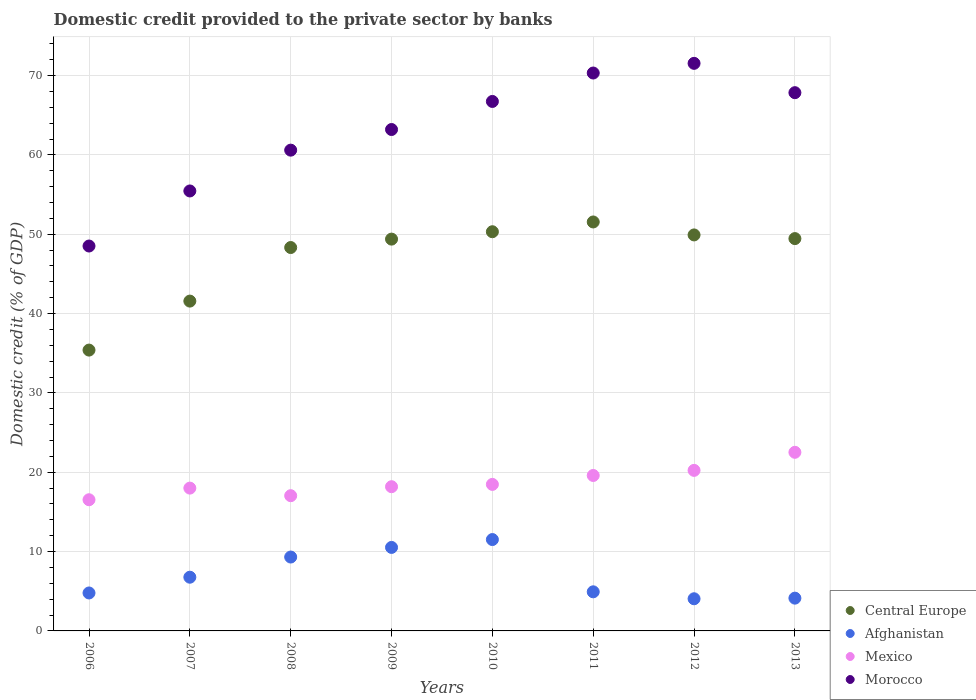How many different coloured dotlines are there?
Your response must be concise. 4. Is the number of dotlines equal to the number of legend labels?
Ensure brevity in your answer.  Yes. What is the domestic credit provided to the private sector by banks in Morocco in 2010?
Keep it short and to the point. 66.74. Across all years, what is the maximum domestic credit provided to the private sector by banks in Morocco?
Provide a succinct answer. 71.55. Across all years, what is the minimum domestic credit provided to the private sector by banks in Mexico?
Offer a terse response. 16.54. In which year was the domestic credit provided to the private sector by banks in Central Europe maximum?
Your answer should be very brief. 2011. What is the total domestic credit provided to the private sector by banks in Central Europe in the graph?
Your answer should be very brief. 375.93. What is the difference between the domestic credit provided to the private sector by banks in Afghanistan in 2007 and that in 2008?
Make the answer very short. -2.54. What is the difference between the domestic credit provided to the private sector by banks in Morocco in 2010 and the domestic credit provided to the private sector by banks in Central Europe in 2009?
Keep it short and to the point. 17.35. What is the average domestic credit provided to the private sector by banks in Mexico per year?
Make the answer very short. 18.82. In the year 2007, what is the difference between the domestic credit provided to the private sector by banks in Afghanistan and domestic credit provided to the private sector by banks in Morocco?
Your answer should be very brief. -48.69. What is the ratio of the domestic credit provided to the private sector by banks in Central Europe in 2007 to that in 2009?
Provide a short and direct response. 0.84. Is the difference between the domestic credit provided to the private sector by banks in Afghanistan in 2007 and 2010 greater than the difference between the domestic credit provided to the private sector by banks in Morocco in 2007 and 2010?
Offer a terse response. Yes. What is the difference between the highest and the second highest domestic credit provided to the private sector by banks in Morocco?
Ensure brevity in your answer.  1.22. What is the difference between the highest and the lowest domestic credit provided to the private sector by banks in Morocco?
Ensure brevity in your answer.  23.03. In how many years, is the domestic credit provided to the private sector by banks in Afghanistan greater than the average domestic credit provided to the private sector by banks in Afghanistan taken over all years?
Your answer should be very brief. 3. Is the sum of the domestic credit provided to the private sector by banks in Central Europe in 2008 and 2013 greater than the maximum domestic credit provided to the private sector by banks in Morocco across all years?
Your response must be concise. Yes. Is it the case that in every year, the sum of the domestic credit provided to the private sector by banks in Central Europe and domestic credit provided to the private sector by banks in Morocco  is greater than the sum of domestic credit provided to the private sector by banks in Afghanistan and domestic credit provided to the private sector by banks in Mexico?
Keep it short and to the point. No. Does the domestic credit provided to the private sector by banks in Morocco monotonically increase over the years?
Provide a succinct answer. No. How many dotlines are there?
Offer a terse response. 4. How many years are there in the graph?
Offer a terse response. 8. Are the values on the major ticks of Y-axis written in scientific E-notation?
Provide a succinct answer. No. Where does the legend appear in the graph?
Provide a short and direct response. Bottom right. How many legend labels are there?
Your answer should be compact. 4. What is the title of the graph?
Provide a short and direct response. Domestic credit provided to the private sector by banks. What is the label or title of the Y-axis?
Your response must be concise. Domestic credit (% of GDP). What is the Domestic credit (% of GDP) of Central Europe in 2006?
Give a very brief answer. 35.4. What is the Domestic credit (% of GDP) in Afghanistan in 2006?
Ensure brevity in your answer.  4.78. What is the Domestic credit (% of GDP) in Mexico in 2006?
Your answer should be compact. 16.54. What is the Domestic credit (% of GDP) of Morocco in 2006?
Ensure brevity in your answer.  48.52. What is the Domestic credit (% of GDP) of Central Europe in 2007?
Offer a very short reply. 41.58. What is the Domestic credit (% of GDP) of Afghanistan in 2007?
Keep it short and to the point. 6.77. What is the Domestic credit (% of GDP) of Mexico in 2007?
Offer a terse response. 18. What is the Domestic credit (% of GDP) of Morocco in 2007?
Offer a terse response. 55.46. What is the Domestic credit (% of GDP) of Central Europe in 2008?
Provide a succinct answer. 48.33. What is the Domestic credit (% of GDP) of Afghanistan in 2008?
Make the answer very short. 9.31. What is the Domestic credit (% of GDP) in Mexico in 2008?
Your answer should be compact. 17.05. What is the Domestic credit (% of GDP) in Morocco in 2008?
Your answer should be very brief. 60.6. What is the Domestic credit (% of GDP) in Central Europe in 2009?
Give a very brief answer. 49.39. What is the Domestic credit (% of GDP) in Afghanistan in 2009?
Offer a very short reply. 10.53. What is the Domestic credit (% of GDP) of Mexico in 2009?
Make the answer very short. 18.18. What is the Domestic credit (% of GDP) in Morocco in 2009?
Offer a terse response. 63.2. What is the Domestic credit (% of GDP) in Central Europe in 2010?
Make the answer very short. 50.32. What is the Domestic credit (% of GDP) of Afghanistan in 2010?
Provide a succinct answer. 11.52. What is the Domestic credit (% of GDP) in Mexico in 2010?
Provide a succinct answer. 18.47. What is the Domestic credit (% of GDP) of Morocco in 2010?
Ensure brevity in your answer.  66.74. What is the Domestic credit (% of GDP) in Central Europe in 2011?
Provide a short and direct response. 51.55. What is the Domestic credit (% of GDP) in Afghanistan in 2011?
Keep it short and to the point. 4.93. What is the Domestic credit (% of GDP) in Mexico in 2011?
Offer a very short reply. 19.59. What is the Domestic credit (% of GDP) in Morocco in 2011?
Your answer should be very brief. 70.33. What is the Domestic credit (% of GDP) of Central Europe in 2012?
Provide a short and direct response. 49.92. What is the Domestic credit (% of GDP) of Afghanistan in 2012?
Your answer should be very brief. 4.05. What is the Domestic credit (% of GDP) in Mexico in 2012?
Your answer should be very brief. 20.24. What is the Domestic credit (% of GDP) of Morocco in 2012?
Keep it short and to the point. 71.55. What is the Domestic credit (% of GDP) in Central Europe in 2013?
Make the answer very short. 49.45. What is the Domestic credit (% of GDP) in Afghanistan in 2013?
Your response must be concise. 4.13. What is the Domestic credit (% of GDP) in Mexico in 2013?
Your answer should be very brief. 22.52. What is the Domestic credit (% of GDP) of Morocco in 2013?
Your answer should be compact. 67.85. Across all years, what is the maximum Domestic credit (% of GDP) in Central Europe?
Offer a very short reply. 51.55. Across all years, what is the maximum Domestic credit (% of GDP) of Afghanistan?
Keep it short and to the point. 11.52. Across all years, what is the maximum Domestic credit (% of GDP) of Mexico?
Make the answer very short. 22.52. Across all years, what is the maximum Domestic credit (% of GDP) of Morocco?
Give a very brief answer. 71.55. Across all years, what is the minimum Domestic credit (% of GDP) in Central Europe?
Offer a very short reply. 35.4. Across all years, what is the minimum Domestic credit (% of GDP) of Afghanistan?
Keep it short and to the point. 4.05. Across all years, what is the minimum Domestic credit (% of GDP) in Mexico?
Your answer should be compact. 16.54. Across all years, what is the minimum Domestic credit (% of GDP) in Morocco?
Offer a very short reply. 48.52. What is the total Domestic credit (% of GDP) in Central Europe in the graph?
Ensure brevity in your answer.  375.93. What is the total Domestic credit (% of GDP) of Afghanistan in the graph?
Your answer should be very brief. 56.02. What is the total Domestic credit (% of GDP) in Mexico in the graph?
Give a very brief answer. 150.58. What is the total Domestic credit (% of GDP) in Morocco in the graph?
Ensure brevity in your answer.  504.25. What is the difference between the Domestic credit (% of GDP) in Central Europe in 2006 and that in 2007?
Provide a short and direct response. -6.18. What is the difference between the Domestic credit (% of GDP) of Afghanistan in 2006 and that in 2007?
Give a very brief answer. -1.99. What is the difference between the Domestic credit (% of GDP) in Mexico in 2006 and that in 2007?
Your answer should be very brief. -1.47. What is the difference between the Domestic credit (% of GDP) of Morocco in 2006 and that in 2007?
Offer a very short reply. -6.94. What is the difference between the Domestic credit (% of GDP) of Central Europe in 2006 and that in 2008?
Provide a succinct answer. -12.93. What is the difference between the Domestic credit (% of GDP) of Afghanistan in 2006 and that in 2008?
Your answer should be compact. -4.53. What is the difference between the Domestic credit (% of GDP) of Mexico in 2006 and that in 2008?
Ensure brevity in your answer.  -0.51. What is the difference between the Domestic credit (% of GDP) of Morocco in 2006 and that in 2008?
Offer a terse response. -12.08. What is the difference between the Domestic credit (% of GDP) of Central Europe in 2006 and that in 2009?
Offer a very short reply. -13.99. What is the difference between the Domestic credit (% of GDP) in Afghanistan in 2006 and that in 2009?
Ensure brevity in your answer.  -5.74. What is the difference between the Domestic credit (% of GDP) in Mexico in 2006 and that in 2009?
Ensure brevity in your answer.  -1.64. What is the difference between the Domestic credit (% of GDP) in Morocco in 2006 and that in 2009?
Offer a very short reply. -14.69. What is the difference between the Domestic credit (% of GDP) in Central Europe in 2006 and that in 2010?
Give a very brief answer. -14.92. What is the difference between the Domestic credit (% of GDP) in Afghanistan in 2006 and that in 2010?
Your answer should be very brief. -6.73. What is the difference between the Domestic credit (% of GDP) of Mexico in 2006 and that in 2010?
Make the answer very short. -1.93. What is the difference between the Domestic credit (% of GDP) in Morocco in 2006 and that in 2010?
Make the answer very short. -18.22. What is the difference between the Domestic credit (% of GDP) of Central Europe in 2006 and that in 2011?
Your answer should be compact. -16.15. What is the difference between the Domestic credit (% of GDP) of Afghanistan in 2006 and that in 2011?
Give a very brief answer. -0.14. What is the difference between the Domestic credit (% of GDP) of Mexico in 2006 and that in 2011?
Offer a very short reply. -3.06. What is the difference between the Domestic credit (% of GDP) in Morocco in 2006 and that in 2011?
Offer a terse response. -21.81. What is the difference between the Domestic credit (% of GDP) of Central Europe in 2006 and that in 2012?
Your answer should be compact. -14.52. What is the difference between the Domestic credit (% of GDP) of Afghanistan in 2006 and that in 2012?
Your answer should be very brief. 0.73. What is the difference between the Domestic credit (% of GDP) of Mexico in 2006 and that in 2012?
Your answer should be very brief. -3.7. What is the difference between the Domestic credit (% of GDP) in Morocco in 2006 and that in 2012?
Ensure brevity in your answer.  -23.03. What is the difference between the Domestic credit (% of GDP) of Central Europe in 2006 and that in 2013?
Give a very brief answer. -14.05. What is the difference between the Domestic credit (% of GDP) of Afghanistan in 2006 and that in 2013?
Offer a terse response. 0.65. What is the difference between the Domestic credit (% of GDP) of Mexico in 2006 and that in 2013?
Offer a very short reply. -5.98. What is the difference between the Domestic credit (% of GDP) in Morocco in 2006 and that in 2013?
Keep it short and to the point. -19.33. What is the difference between the Domestic credit (% of GDP) of Central Europe in 2007 and that in 2008?
Give a very brief answer. -6.75. What is the difference between the Domestic credit (% of GDP) of Afghanistan in 2007 and that in 2008?
Offer a very short reply. -2.54. What is the difference between the Domestic credit (% of GDP) in Mexico in 2007 and that in 2008?
Give a very brief answer. 0.96. What is the difference between the Domestic credit (% of GDP) in Morocco in 2007 and that in 2008?
Provide a short and direct response. -5.14. What is the difference between the Domestic credit (% of GDP) in Central Europe in 2007 and that in 2009?
Offer a terse response. -7.81. What is the difference between the Domestic credit (% of GDP) of Afghanistan in 2007 and that in 2009?
Give a very brief answer. -3.76. What is the difference between the Domestic credit (% of GDP) in Mexico in 2007 and that in 2009?
Provide a short and direct response. -0.18. What is the difference between the Domestic credit (% of GDP) in Morocco in 2007 and that in 2009?
Offer a terse response. -7.75. What is the difference between the Domestic credit (% of GDP) of Central Europe in 2007 and that in 2010?
Provide a short and direct response. -8.74. What is the difference between the Domestic credit (% of GDP) in Afghanistan in 2007 and that in 2010?
Offer a very short reply. -4.75. What is the difference between the Domestic credit (% of GDP) in Mexico in 2007 and that in 2010?
Offer a very short reply. -0.47. What is the difference between the Domestic credit (% of GDP) of Morocco in 2007 and that in 2010?
Your answer should be very brief. -11.28. What is the difference between the Domestic credit (% of GDP) of Central Europe in 2007 and that in 2011?
Ensure brevity in your answer.  -9.98. What is the difference between the Domestic credit (% of GDP) of Afghanistan in 2007 and that in 2011?
Your answer should be very brief. 1.84. What is the difference between the Domestic credit (% of GDP) in Mexico in 2007 and that in 2011?
Provide a short and direct response. -1.59. What is the difference between the Domestic credit (% of GDP) in Morocco in 2007 and that in 2011?
Your answer should be compact. -14.87. What is the difference between the Domestic credit (% of GDP) in Central Europe in 2007 and that in 2012?
Your answer should be compact. -8.34. What is the difference between the Domestic credit (% of GDP) of Afghanistan in 2007 and that in 2012?
Offer a very short reply. 2.72. What is the difference between the Domestic credit (% of GDP) in Mexico in 2007 and that in 2012?
Your answer should be very brief. -2.24. What is the difference between the Domestic credit (% of GDP) of Morocco in 2007 and that in 2012?
Offer a very short reply. -16.09. What is the difference between the Domestic credit (% of GDP) in Central Europe in 2007 and that in 2013?
Provide a succinct answer. -7.88. What is the difference between the Domestic credit (% of GDP) in Afghanistan in 2007 and that in 2013?
Provide a short and direct response. 2.64. What is the difference between the Domestic credit (% of GDP) of Mexico in 2007 and that in 2013?
Make the answer very short. -4.51. What is the difference between the Domestic credit (% of GDP) in Morocco in 2007 and that in 2013?
Keep it short and to the point. -12.39. What is the difference between the Domestic credit (% of GDP) of Central Europe in 2008 and that in 2009?
Your answer should be compact. -1.06. What is the difference between the Domestic credit (% of GDP) of Afghanistan in 2008 and that in 2009?
Keep it short and to the point. -1.21. What is the difference between the Domestic credit (% of GDP) in Mexico in 2008 and that in 2009?
Offer a very short reply. -1.13. What is the difference between the Domestic credit (% of GDP) in Morocco in 2008 and that in 2009?
Provide a succinct answer. -2.6. What is the difference between the Domestic credit (% of GDP) of Central Europe in 2008 and that in 2010?
Your response must be concise. -1.99. What is the difference between the Domestic credit (% of GDP) of Afghanistan in 2008 and that in 2010?
Offer a very short reply. -2.2. What is the difference between the Domestic credit (% of GDP) in Mexico in 2008 and that in 2010?
Your answer should be compact. -1.42. What is the difference between the Domestic credit (% of GDP) in Morocco in 2008 and that in 2010?
Your answer should be very brief. -6.14. What is the difference between the Domestic credit (% of GDP) in Central Europe in 2008 and that in 2011?
Your answer should be very brief. -3.22. What is the difference between the Domestic credit (% of GDP) of Afghanistan in 2008 and that in 2011?
Make the answer very short. 4.38. What is the difference between the Domestic credit (% of GDP) in Mexico in 2008 and that in 2011?
Offer a very short reply. -2.55. What is the difference between the Domestic credit (% of GDP) of Morocco in 2008 and that in 2011?
Keep it short and to the point. -9.72. What is the difference between the Domestic credit (% of GDP) of Central Europe in 2008 and that in 2012?
Your answer should be compact. -1.59. What is the difference between the Domestic credit (% of GDP) in Afghanistan in 2008 and that in 2012?
Your answer should be compact. 5.26. What is the difference between the Domestic credit (% of GDP) in Mexico in 2008 and that in 2012?
Your answer should be compact. -3.19. What is the difference between the Domestic credit (% of GDP) in Morocco in 2008 and that in 2012?
Your answer should be very brief. -10.94. What is the difference between the Domestic credit (% of GDP) in Central Europe in 2008 and that in 2013?
Your answer should be compact. -1.13. What is the difference between the Domestic credit (% of GDP) of Afghanistan in 2008 and that in 2013?
Offer a very short reply. 5.18. What is the difference between the Domestic credit (% of GDP) in Mexico in 2008 and that in 2013?
Provide a succinct answer. -5.47. What is the difference between the Domestic credit (% of GDP) of Morocco in 2008 and that in 2013?
Offer a very short reply. -7.24. What is the difference between the Domestic credit (% of GDP) of Central Europe in 2009 and that in 2010?
Your response must be concise. -0.93. What is the difference between the Domestic credit (% of GDP) of Afghanistan in 2009 and that in 2010?
Offer a very short reply. -0.99. What is the difference between the Domestic credit (% of GDP) in Mexico in 2009 and that in 2010?
Give a very brief answer. -0.29. What is the difference between the Domestic credit (% of GDP) in Morocco in 2009 and that in 2010?
Provide a succinct answer. -3.54. What is the difference between the Domestic credit (% of GDP) in Central Europe in 2009 and that in 2011?
Give a very brief answer. -2.16. What is the difference between the Domestic credit (% of GDP) in Afghanistan in 2009 and that in 2011?
Ensure brevity in your answer.  5.6. What is the difference between the Domestic credit (% of GDP) of Mexico in 2009 and that in 2011?
Your answer should be compact. -1.42. What is the difference between the Domestic credit (% of GDP) in Morocco in 2009 and that in 2011?
Ensure brevity in your answer.  -7.12. What is the difference between the Domestic credit (% of GDP) in Central Europe in 2009 and that in 2012?
Your response must be concise. -0.53. What is the difference between the Domestic credit (% of GDP) in Afghanistan in 2009 and that in 2012?
Offer a terse response. 6.47. What is the difference between the Domestic credit (% of GDP) of Mexico in 2009 and that in 2012?
Offer a terse response. -2.06. What is the difference between the Domestic credit (% of GDP) of Morocco in 2009 and that in 2012?
Your response must be concise. -8.34. What is the difference between the Domestic credit (% of GDP) of Central Europe in 2009 and that in 2013?
Provide a short and direct response. -0.07. What is the difference between the Domestic credit (% of GDP) in Afghanistan in 2009 and that in 2013?
Offer a terse response. 6.39. What is the difference between the Domestic credit (% of GDP) of Mexico in 2009 and that in 2013?
Provide a succinct answer. -4.34. What is the difference between the Domestic credit (% of GDP) of Morocco in 2009 and that in 2013?
Offer a very short reply. -4.64. What is the difference between the Domestic credit (% of GDP) in Central Europe in 2010 and that in 2011?
Your answer should be compact. -1.23. What is the difference between the Domestic credit (% of GDP) in Afghanistan in 2010 and that in 2011?
Provide a short and direct response. 6.59. What is the difference between the Domestic credit (% of GDP) in Mexico in 2010 and that in 2011?
Offer a terse response. -1.12. What is the difference between the Domestic credit (% of GDP) of Morocco in 2010 and that in 2011?
Make the answer very short. -3.58. What is the difference between the Domestic credit (% of GDP) of Central Europe in 2010 and that in 2012?
Provide a short and direct response. 0.4. What is the difference between the Domestic credit (% of GDP) of Afghanistan in 2010 and that in 2012?
Your response must be concise. 7.46. What is the difference between the Domestic credit (% of GDP) of Mexico in 2010 and that in 2012?
Provide a succinct answer. -1.77. What is the difference between the Domestic credit (% of GDP) in Morocco in 2010 and that in 2012?
Your answer should be very brief. -4.8. What is the difference between the Domestic credit (% of GDP) of Central Europe in 2010 and that in 2013?
Make the answer very short. 0.87. What is the difference between the Domestic credit (% of GDP) of Afghanistan in 2010 and that in 2013?
Keep it short and to the point. 7.39. What is the difference between the Domestic credit (% of GDP) in Mexico in 2010 and that in 2013?
Your answer should be compact. -4.05. What is the difference between the Domestic credit (% of GDP) of Morocco in 2010 and that in 2013?
Your answer should be very brief. -1.11. What is the difference between the Domestic credit (% of GDP) in Central Europe in 2011 and that in 2012?
Your answer should be compact. 1.63. What is the difference between the Domestic credit (% of GDP) of Mexico in 2011 and that in 2012?
Your answer should be compact. -0.64. What is the difference between the Domestic credit (% of GDP) in Morocco in 2011 and that in 2012?
Keep it short and to the point. -1.22. What is the difference between the Domestic credit (% of GDP) in Central Europe in 2011 and that in 2013?
Your answer should be very brief. 2.1. What is the difference between the Domestic credit (% of GDP) of Afghanistan in 2011 and that in 2013?
Give a very brief answer. 0.8. What is the difference between the Domestic credit (% of GDP) of Mexico in 2011 and that in 2013?
Keep it short and to the point. -2.92. What is the difference between the Domestic credit (% of GDP) of Morocco in 2011 and that in 2013?
Provide a succinct answer. 2.48. What is the difference between the Domestic credit (% of GDP) in Central Europe in 2012 and that in 2013?
Provide a short and direct response. 0.46. What is the difference between the Domestic credit (% of GDP) of Afghanistan in 2012 and that in 2013?
Provide a succinct answer. -0.08. What is the difference between the Domestic credit (% of GDP) of Mexico in 2012 and that in 2013?
Give a very brief answer. -2.28. What is the difference between the Domestic credit (% of GDP) in Morocco in 2012 and that in 2013?
Keep it short and to the point. 3.7. What is the difference between the Domestic credit (% of GDP) of Central Europe in 2006 and the Domestic credit (% of GDP) of Afghanistan in 2007?
Offer a terse response. 28.63. What is the difference between the Domestic credit (% of GDP) of Central Europe in 2006 and the Domestic credit (% of GDP) of Mexico in 2007?
Your answer should be compact. 17.4. What is the difference between the Domestic credit (% of GDP) of Central Europe in 2006 and the Domestic credit (% of GDP) of Morocco in 2007?
Offer a very short reply. -20.06. What is the difference between the Domestic credit (% of GDP) of Afghanistan in 2006 and the Domestic credit (% of GDP) of Mexico in 2007?
Provide a succinct answer. -13.22. What is the difference between the Domestic credit (% of GDP) in Afghanistan in 2006 and the Domestic credit (% of GDP) in Morocco in 2007?
Keep it short and to the point. -50.67. What is the difference between the Domestic credit (% of GDP) in Mexico in 2006 and the Domestic credit (% of GDP) in Morocco in 2007?
Ensure brevity in your answer.  -38.92. What is the difference between the Domestic credit (% of GDP) in Central Europe in 2006 and the Domestic credit (% of GDP) in Afghanistan in 2008?
Keep it short and to the point. 26.09. What is the difference between the Domestic credit (% of GDP) of Central Europe in 2006 and the Domestic credit (% of GDP) of Mexico in 2008?
Keep it short and to the point. 18.35. What is the difference between the Domestic credit (% of GDP) in Central Europe in 2006 and the Domestic credit (% of GDP) in Morocco in 2008?
Your answer should be compact. -25.2. What is the difference between the Domestic credit (% of GDP) in Afghanistan in 2006 and the Domestic credit (% of GDP) in Mexico in 2008?
Ensure brevity in your answer.  -12.26. What is the difference between the Domestic credit (% of GDP) in Afghanistan in 2006 and the Domestic credit (% of GDP) in Morocco in 2008?
Give a very brief answer. -55.82. What is the difference between the Domestic credit (% of GDP) in Mexico in 2006 and the Domestic credit (% of GDP) in Morocco in 2008?
Your answer should be very brief. -44.07. What is the difference between the Domestic credit (% of GDP) in Central Europe in 2006 and the Domestic credit (% of GDP) in Afghanistan in 2009?
Offer a terse response. 24.87. What is the difference between the Domestic credit (% of GDP) of Central Europe in 2006 and the Domestic credit (% of GDP) of Mexico in 2009?
Keep it short and to the point. 17.22. What is the difference between the Domestic credit (% of GDP) in Central Europe in 2006 and the Domestic credit (% of GDP) in Morocco in 2009?
Keep it short and to the point. -27.8. What is the difference between the Domestic credit (% of GDP) in Afghanistan in 2006 and the Domestic credit (% of GDP) in Mexico in 2009?
Give a very brief answer. -13.39. What is the difference between the Domestic credit (% of GDP) of Afghanistan in 2006 and the Domestic credit (% of GDP) of Morocco in 2009?
Give a very brief answer. -58.42. What is the difference between the Domestic credit (% of GDP) in Mexico in 2006 and the Domestic credit (% of GDP) in Morocco in 2009?
Your answer should be compact. -46.67. What is the difference between the Domestic credit (% of GDP) in Central Europe in 2006 and the Domestic credit (% of GDP) in Afghanistan in 2010?
Provide a succinct answer. 23.88. What is the difference between the Domestic credit (% of GDP) of Central Europe in 2006 and the Domestic credit (% of GDP) of Mexico in 2010?
Provide a short and direct response. 16.93. What is the difference between the Domestic credit (% of GDP) of Central Europe in 2006 and the Domestic credit (% of GDP) of Morocco in 2010?
Your response must be concise. -31.34. What is the difference between the Domestic credit (% of GDP) of Afghanistan in 2006 and the Domestic credit (% of GDP) of Mexico in 2010?
Your response must be concise. -13.69. What is the difference between the Domestic credit (% of GDP) of Afghanistan in 2006 and the Domestic credit (% of GDP) of Morocco in 2010?
Provide a short and direct response. -61.96. What is the difference between the Domestic credit (% of GDP) in Mexico in 2006 and the Domestic credit (% of GDP) in Morocco in 2010?
Provide a succinct answer. -50.21. What is the difference between the Domestic credit (% of GDP) in Central Europe in 2006 and the Domestic credit (% of GDP) in Afghanistan in 2011?
Provide a succinct answer. 30.47. What is the difference between the Domestic credit (% of GDP) of Central Europe in 2006 and the Domestic credit (% of GDP) of Mexico in 2011?
Offer a very short reply. 15.81. What is the difference between the Domestic credit (% of GDP) in Central Europe in 2006 and the Domestic credit (% of GDP) in Morocco in 2011?
Offer a terse response. -34.93. What is the difference between the Domestic credit (% of GDP) of Afghanistan in 2006 and the Domestic credit (% of GDP) of Mexico in 2011?
Your answer should be compact. -14.81. What is the difference between the Domestic credit (% of GDP) in Afghanistan in 2006 and the Domestic credit (% of GDP) in Morocco in 2011?
Offer a terse response. -65.54. What is the difference between the Domestic credit (% of GDP) of Mexico in 2006 and the Domestic credit (% of GDP) of Morocco in 2011?
Keep it short and to the point. -53.79. What is the difference between the Domestic credit (% of GDP) of Central Europe in 2006 and the Domestic credit (% of GDP) of Afghanistan in 2012?
Provide a short and direct response. 31.35. What is the difference between the Domestic credit (% of GDP) of Central Europe in 2006 and the Domestic credit (% of GDP) of Mexico in 2012?
Provide a short and direct response. 15.16. What is the difference between the Domestic credit (% of GDP) in Central Europe in 2006 and the Domestic credit (% of GDP) in Morocco in 2012?
Offer a terse response. -36.15. What is the difference between the Domestic credit (% of GDP) of Afghanistan in 2006 and the Domestic credit (% of GDP) of Mexico in 2012?
Provide a succinct answer. -15.45. What is the difference between the Domestic credit (% of GDP) in Afghanistan in 2006 and the Domestic credit (% of GDP) in Morocco in 2012?
Provide a succinct answer. -66.76. What is the difference between the Domestic credit (% of GDP) in Mexico in 2006 and the Domestic credit (% of GDP) in Morocco in 2012?
Your answer should be compact. -55.01. What is the difference between the Domestic credit (% of GDP) in Central Europe in 2006 and the Domestic credit (% of GDP) in Afghanistan in 2013?
Give a very brief answer. 31.27. What is the difference between the Domestic credit (% of GDP) of Central Europe in 2006 and the Domestic credit (% of GDP) of Mexico in 2013?
Give a very brief answer. 12.88. What is the difference between the Domestic credit (% of GDP) in Central Europe in 2006 and the Domestic credit (% of GDP) in Morocco in 2013?
Provide a short and direct response. -32.45. What is the difference between the Domestic credit (% of GDP) in Afghanistan in 2006 and the Domestic credit (% of GDP) in Mexico in 2013?
Give a very brief answer. -17.73. What is the difference between the Domestic credit (% of GDP) of Afghanistan in 2006 and the Domestic credit (% of GDP) of Morocco in 2013?
Provide a succinct answer. -63.06. What is the difference between the Domestic credit (% of GDP) in Mexico in 2006 and the Domestic credit (% of GDP) in Morocco in 2013?
Make the answer very short. -51.31. What is the difference between the Domestic credit (% of GDP) in Central Europe in 2007 and the Domestic credit (% of GDP) in Afghanistan in 2008?
Offer a very short reply. 32.26. What is the difference between the Domestic credit (% of GDP) of Central Europe in 2007 and the Domestic credit (% of GDP) of Mexico in 2008?
Your answer should be compact. 24.53. What is the difference between the Domestic credit (% of GDP) in Central Europe in 2007 and the Domestic credit (% of GDP) in Morocco in 2008?
Offer a terse response. -19.03. What is the difference between the Domestic credit (% of GDP) in Afghanistan in 2007 and the Domestic credit (% of GDP) in Mexico in 2008?
Ensure brevity in your answer.  -10.28. What is the difference between the Domestic credit (% of GDP) in Afghanistan in 2007 and the Domestic credit (% of GDP) in Morocco in 2008?
Provide a succinct answer. -53.83. What is the difference between the Domestic credit (% of GDP) of Mexico in 2007 and the Domestic credit (% of GDP) of Morocco in 2008?
Give a very brief answer. -42.6. What is the difference between the Domestic credit (% of GDP) of Central Europe in 2007 and the Domestic credit (% of GDP) of Afghanistan in 2009?
Your answer should be very brief. 31.05. What is the difference between the Domestic credit (% of GDP) of Central Europe in 2007 and the Domestic credit (% of GDP) of Mexico in 2009?
Provide a short and direct response. 23.4. What is the difference between the Domestic credit (% of GDP) of Central Europe in 2007 and the Domestic credit (% of GDP) of Morocco in 2009?
Make the answer very short. -21.63. What is the difference between the Domestic credit (% of GDP) in Afghanistan in 2007 and the Domestic credit (% of GDP) in Mexico in 2009?
Your answer should be compact. -11.41. What is the difference between the Domestic credit (% of GDP) in Afghanistan in 2007 and the Domestic credit (% of GDP) in Morocco in 2009?
Make the answer very short. -56.43. What is the difference between the Domestic credit (% of GDP) in Mexico in 2007 and the Domestic credit (% of GDP) in Morocco in 2009?
Your response must be concise. -45.2. What is the difference between the Domestic credit (% of GDP) of Central Europe in 2007 and the Domestic credit (% of GDP) of Afghanistan in 2010?
Provide a succinct answer. 30.06. What is the difference between the Domestic credit (% of GDP) in Central Europe in 2007 and the Domestic credit (% of GDP) in Mexico in 2010?
Offer a terse response. 23.11. What is the difference between the Domestic credit (% of GDP) in Central Europe in 2007 and the Domestic credit (% of GDP) in Morocco in 2010?
Give a very brief answer. -25.17. What is the difference between the Domestic credit (% of GDP) of Afghanistan in 2007 and the Domestic credit (% of GDP) of Mexico in 2010?
Give a very brief answer. -11.7. What is the difference between the Domestic credit (% of GDP) of Afghanistan in 2007 and the Domestic credit (% of GDP) of Morocco in 2010?
Offer a terse response. -59.97. What is the difference between the Domestic credit (% of GDP) of Mexico in 2007 and the Domestic credit (% of GDP) of Morocco in 2010?
Your answer should be very brief. -48.74. What is the difference between the Domestic credit (% of GDP) in Central Europe in 2007 and the Domestic credit (% of GDP) in Afghanistan in 2011?
Offer a very short reply. 36.65. What is the difference between the Domestic credit (% of GDP) of Central Europe in 2007 and the Domestic credit (% of GDP) of Mexico in 2011?
Your answer should be compact. 21.98. What is the difference between the Domestic credit (% of GDP) of Central Europe in 2007 and the Domestic credit (% of GDP) of Morocco in 2011?
Ensure brevity in your answer.  -28.75. What is the difference between the Domestic credit (% of GDP) of Afghanistan in 2007 and the Domestic credit (% of GDP) of Mexico in 2011?
Provide a short and direct response. -12.82. What is the difference between the Domestic credit (% of GDP) in Afghanistan in 2007 and the Domestic credit (% of GDP) in Morocco in 2011?
Offer a very short reply. -63.56. What is the difference between the Domestic credit (% of GDP) of Mexico in 2007 and the Domestic credit (% of GDP) of Morocco in 2011?
Your answer should be compact. -52.32. What is the difference between the Domestic credit (% of GDP) of Central Europe in 2007 and the Domestic credit (% of GDP) of Afghanistan in 2012?
Offer a very short reply. 37.52. What is the difference between the Domestic credit (% of GDP) in Central Europe in 2007 and the Domestic credit (% of GDP) in Mexico in 2012?
Your answer should be very brief. 21.34. What is the difference between the Domestic credit (% of GDP) of Central Europe in 2007 and the Domestic credit (% of GDP) of Morocco in 2012?
Provide a short and direct response. -29.97. What is the difference between the Domestic credit (% of GDP) of Afghanistan in 2007 and the Domestic credit (% of GDP) of Mexico in 2012?
Give a very brief answer. -13.47. What is the difference between the Domestic credit (% of GDP) of Afghanistan in 2007 and the Domestic credit (% of GDP) of Morocco in 2012?
Offer a terse response. -64.78. What is the difference between the Domestic credit (% of GDP) of Mexico in 2007 and the Domestic credit (% of GDP) of Morocco in 2012?
Ensure brevity in your answer.  -53.54. What is the difference between the Domestic credit (% of GDP) of Central Europe in 2007 and the Domestic credit (% of GDP) of Afghanistan in 2013?
Keep it short and to the point. 37.44. What is the difference between the Domestic credit (% of GDP) in Central Europe in 2007 and the Domestic credit (% of GDP) in Mexico in 2013?
Give a very brief answer. 19.06. What is the difference between the Domestic credit (% of GDP) of Central Europe in 2007 and the Domestic credit (% of GDP) of Morocco in 2013?
Your answer should be compact. -26.27. What is the difference between the Domestic credit (% of GDP) in Afghanistan in 2007 and the Domestic credit (% of GDP) in Mexico in 2013?
Provide a succinct answer. -15.75. What is the difference between the Domestic credit (% of GDP) in Afghanistan in 2007 and the Domestic credit (% of GDP) in Morocco in 2013?
Provide a succinct answer. -61.08. What is the difference between the Domestic credit (% of GDP) in Mexico in 2007 and the Domestic credit (% of GDP) in Morocco in 2013?
Your response must be concise. -49.85. What is the difference between the Domestic credit (% of GDP) of Central Europe in 2008 and the Domestic credit (% of GDP) of Afghanistan in 2009?
Offer a very short reply. 37.8. What is the difference between the Domestic credit (% of GDP) in Central Europe in 2008 and the Domestic credit (% of GDP) in Mexico in 2009?
Your answer should be very brief. 30.15. What is the difference between the Domestic credit (% of GDP) in Central Europe in 2008 and the Domestic credit (% of GDP) in Morocco in 2009?
Your answer should be very brief. -14.88. What is the difference between the Domestic credit (% of GDP) in Afghanistan in 2008 and the Domestic credit (% of GDP) in Mexico in 2009?
Provide a succinct answer. -8.87. What is the difference between the Domestic credit (% of GDP) of Afghanistan in 2008 and the Domestic credit (% of GDP) of Morocco in 2009?
Offer a very short reply. -53.89. What is the difference between the Domestic credit (% of GDP) in Mexico in 2008 and the Domestic credit (% of GDP) in Morocco in 2009?
Offer a very short reply. -46.16. What is the difference between the Domestic credit (% of GDP) of Central Europe in 2008 and the Domestic credit (% of GDP) of Afghanistan in 2010?
Your answer should be compact. 36.81. What is the difference between the Domestic credit (% of GDP) in Central Europe in 2008 and the Domestic credit (% of GDP) in Mexico in 2010?
Offer a very short reply. 29.86. What is the difference between the Domestic credit (% of GDP) of Central Europe in 2008 and the Domestic credit (% of GDP) of Morocco in 2010?
Offer a terse response. -18.41. What is the difference between the Domestic credit (% of GDP) in Afghanistan in 2008 and the Domestic credit (% of GDP) in Mexico in 2010?
Your answer should be very brief. -9.16. What is the difference between the Domestic credit (% of GDP) of Afghanistan in 2008 and the Domestic credit (% of GDP) of Morocco in 2010?
Your response must be concise. -57.43. What is the difference between the Domestic credit (% of GDP) in Mexico in 2008 and the Domestic credit (% of GDP) in Morocco in 2010?
Provide a short and direct response. -49.7. What is the difference between the Domestic credit (% of GDP) of Central Europe in 2008 and the Domestic credit (% of GDP) of Afghanistan in 2011?
Your answer should be very brief. 43.4. What is the difference between the Domestic credit (% of GDP) in Central Europe in 2008 and the Domestic credit (% of GDP) in Mexico in 2011?
Keep it short and to the point. 28.73. What is the difference between the Domestic credit (% of GDP) of Central Europe in 2008 and the Domestic credit (% of GDP) of Morocco in 2011?
Provide a short and direct response. -22. What is the difference between the Domestic credit (% of GDP) of Afghanistan in 2008 and the Domestic credit (% of GDP) of Mexico in 2011?
Provide a succinct answer. -10.28. What is the difference between the Domestic credit (% of GDP) in Afghanistan in 2008 and the Domestic credit (% of GDP) in Morocco in 2011?
Provide a succinct answer. -61.01. What is the difference between the Domestic credit (% of GDP) in Mexico in 2008 and the Domestic credit (% of GDP) in Morocco in 2011?
Keep it short and to the point. -53.28. What is the difference between the Domestic credit (% of GDP) in Central Europe in 2008 and the Domestic credit (% of GDP) in Afghanistan in 2012?
Give a very brief answer. 44.27. What is the difference between the Domestic credit (% of GDP) in Central Europe in 2008 and the Domestic credit (% of GDP) in Mexico in 2012?
Offer a very short reply. 28.09. What is the difference between the Domestic credit (% of GDP) in Central Europe in 2008 and the Domestic credit (% of GDP) in Morocco in 2012?
Give a very brief answer. -23.22. What is the difference between the Domestic credit (% of GDP) in Afghanistan in 2008 and the Domestic credit (% of GDP) in Mexico in 2012?
Ensure brevity in your answer.  -10.92. What is the difference between the Domestic credit (% of GDP) of Afghanistan in 2008 and the Domestic credit (% of GDP) of Morocco in 2012?
Give a very brief answer. -62.23. What is the difference between the Domestic credit (% of GDP) in Mexico in 2008 and the Domestic credit (% of GDP) in Morocco in 2012?
Offer a terse response. -54.5. What is the difference between the Domestic credit (% of GDP) in Central Europe in 2008 and the Domestic credit (% of GDP) in Afghanistan in 2013?
Offer a very short reply. 44.2. What is the difference between the Domestic credit (% of GDP) of Central Europe in 2008 and the Domestic credit (% of GDP) of Mexico in 2013?
Your answer should be very brief. 25.81. What is the difference between the Domestic credit (% of GDP) of Central Europe in 2008 and the Domestic credit (% of GDP) of Morocco in 2013?
Offer a terse response. -19.52. What is the difference between the Domestic credit (% of GDP) of Afghanistan in 2008 and the Domestic credit (% of GDP) of Mexico in 2013?
Your answer should be very brief. -13.2. What is the difference between the Domestic credit (% of GDP) of Afghanistan in 2008 and the Domestic credit (% of GDP) of Morocco in 2013?
Offer a terse response. -58.53. What is the difference between the Domestic credit (% of GDP) of Mexico in 2008 and the Domestic credit (% of GDP) of Morocco in 2013?
Offer a terse response. -50.8. What is the difference between the Domestic credit (% of GDP) of Central Europe in 2009 and the Domestic credit (% of GDP) of Afghanistan in 2010?
Your answer should be compact. 37.87. What is the difference between the Domestic credit (% of GDP) in Central Europe in 2009 and the Domestic credit (% of GDP) in Mexico in 2010?
Your response must be concise. 30.92. What is the difference between the Domestic credit (% of GDP) of Central Europe in 2009 and the Domestic credit (% of GDP) of Morocco in 2010?
Give a very brief answer. -17.35. What is the difference between the Domestic credit (% of GDP) of Afghanistan in 2009 and the Domestic credit (% of GDP) of Mexico in 2010?
Offer a terse response. -7.94. What is the difference between the Domestic credit (% of GDP) in Afghanistan in 2009 and the Domestic credit (% of GDP) in Morocco in 2010?
Offer a very short reply. -56.22. What is the difference between the Domestic credit (% of GDP) in Mexico in 2009 and the Domestic credit (% of GDP) in Morocco in 2010?
Offer a very short reply. -48.56. What is the difference between the Domestic credit (% of GDP) in Central Europe in 2009 and the Domestic credit (% of GDP) in Afghanistan in 2011?
Offer a terse response. 44.46. What is the difference between the Domestic credit (% of GDP) in Central Europe in 2009 and the Domestic credit (% of GDP) in Mexico in 2011?
Your answer should be very brief. 29.79. What is the difference between the Domestic credit (% of GDP) of Central Europe in 2009 and the Domestic credit (% of GDP) of Morocco in 2011?
Provide a short and direct response. -20.94. What is the difference between the Domestic credit (% of GDP) in Afghanistan in 2009 and the Domestic credit (% of GDP) in Mexico in 2011?
Ensure brevity in your answer.  -9.07. What is the difference between the Domestic credit (% of GDP) in Afghanistan in 2009 and the Domestic credit (% of GDP) in Morocco in 2011?
Offer a terse response. -59.8. What is the difference between the Domestic credit (% of GDP) in Mexico in 2009 and the Domestic credit (% of GDP) in Morocco in 2011?
Your response must be concise. -52.15. What is the difference between the Domestic credit (% of GDP) in Central Europe in 2009 and the Domestic credit (% of GDP) in Afghanistan in 2012?
Ensure brevity in your answer.  45.33. What is the difference between the Domestic credit (% of GDP) of Central Europe in 2009 and the Domestic credit (% of GDP) of Mexico in 2012?
Your answer should be very brief. 29.15. What is the difference between the Domestic credit (% of GDP) of Central Europe in 2009 and the Domestic credit (% of GDP) of Morocco in 2012?
Provide a succinct answer. -22.16. What is the difference between the Domestic credit (% of GDP) of Afghanistan in 2009 and the Domestic credit (% of GDP) of Mexico in 2012?
Your answer should be very brief. -9.71. What is the difference between the Domestic credit (% of GDP) in Afghanistan in 2009 and the Domestic credit (% of GDP) in Morocco in 2012?
Your answer should be very brief. -61.02. What is the difference between the Domestic credit (% of GDP) of Mexico in 2009 and the Domestic credit (% of GDP) of Morocco in 2012?
Offer a terse response. -53.37. What is the difference between the Domestic credit (% of GDP) in Central Europe in 2009 and the Domestic credit (% of GDP) in Afghanistan in 2013?
Make the answer very short. 45.26. What is the difference between the Domestic credit (% of GDP) of Central Europe in 2009 and the Domestic credit (% of GDP) of Mexico in 2013?
Your response must be concise. 26.87. What is the difference between the Domestic credit (% of GDP) in Central Europe in 2009 and the Domestic credit (% of GDP) in Morocco in 2013?
Provide a short and direct response. -18.46. What is the difference between the Domestic credit (% of GDP) of Afghanistan in 2009 and the Domestic credit (% of GDP) of Mexico in 2013?
Give a very brief answer. -11.99. What is the difference between the Domestic credit (% of GDP) in Afghanistan in 2009 and the Domestic credit (% of GDP) in Morocco in 2013?
Provide a short and direct response. -57.32. What is the difference between the Domestic credit (% of GDP) in Mexico in 2009 and the Domestic credit (% of GDP) in Morocco in 2013?
Ensure brevity in your answer.  -49.67. What is the difference between the Domestic credit (% of GDP) of Central Europe in 2010 and the Domestic credit (% of GDP) of Afghanistan in 2011?
Your response must be concise. 45.39. What is the difference between the Domestic credit (% of GDP) of Central Europe in 2010 and the Domestic credit (% of GDP) of Mexico in 2011?
Your response must be concise. 30.72. What is the difference between the Domestic credit (% of GDP) of Central Europe in 2010 and the Domestic credit (% of GDP) of Morocco in 2011?
Give a very brief answer. -20.01. What is the difference between the Domestic credit (% of GDP) of Afghanistan in 2010 and the Domestic credit (% of GDP) of Mexico in 2011?
Provide a succinct answer. -8.08. What is the difference between the Domestic credit (% of GDP) of Afghanistan in 2010 and the Domestic credit (% of GDP) of Morocco in 2011?
Your response must be concise. -58.81. What is the difference between the Domestic credit (% of GDP) in Mexico in 2010 and the Domestic credit (% of GDP) in Morocco in 2011?
Keep it short and to the point. -51.86. What is the difference between the Domestic credit (% of GDP) in Central Europe in 2010 and the Domestic credit (% of GDP) in Afghanistan in 2012?
Offer a terse response. 46.27. What is the difference between the Domestic credit (% of GDP) of Central Europe in 2010 and the Domestic credit (% of GDP) of Mexico in 2012?
Provide a short and direct response. 30.08. What is the difference between the Domestic credit (% of GDP) in Central Europe in 2010 and the Domestic credit (% of GDP) in Morocco in 2012?
Offer a terse response. -21.23. What is the difference between the Domestic credit (% of GDP) of Afghanistan in 2010 and the Domestic credit (% of GDP) of Mexico in 2012?
Keep it short and to the point. -8.72. What is the difference between the Domestic credit (% of GDP) of Afghanistan in 2010 and the Domestic credit (% of GDP) of Morocco in 2012?
Ensure brevity in your answer.  -60.03. What is the difference between the Domestic credit (% of GDP) in Mexico in 2010 and the Domestic credit (% of GDP) in Morocco in 2012?
Your answer should be compact. -53.08. What is the difference between the Domestic credit (% of GDP) in Central Europe in 2010 and the Domestic credit (% of GDP) in Afghanistan in 2013?
Your answer should be compact. 46.19. What is the difference between the Domestic credit (% of GDP) of Central Europe in 2010 and the Domestic credit (% of GDP) of Mexico in 2013?
Your answer should be compact. 27.8. What is the difference between the Domestic credit (% of GDP) in Central Europe in 2010 and the Domestic credit (% of GDP) in Morocco in 2013?
Provide a short and direct response. -17.53. What is the difference between the Domestic credit (% of GDP) in Afghanistan in 2010 and the Domestic credit (% of GDP) in Mexico in 2013?
Offer a very short reply. -11. What is the difference between the Domestic credit (% of GDP) in Afghanistan in 2010 and the Domestic credit (% of GDP) in Morocco in 2013?
Offer a terse response. -56.33. What is the difference between the Domestic credit (% of GDP) in Mexico in 2010 and the Domestic credit (% of GDP) in Morocco in 2013?
Make the answer very short. -49.38. What is the difference between the Domestic credit (% of GDP) in Central Europe in 2011 and the Domestic credit (% of GDP) in Afghanistan in 2012?
Give a very brief answer. 47.5. What is the difference between the Domestic credit (% of GDP) of Central Europe in 2011 and the Domestic credit (% of GDP) of Mexico in 2012?
Offer a very short reply. 31.31. What is the difference between the Domestic credit (% of GDP) in Central Europe in 2011 and the Domestic credit (% of GDP) in Morocco in 2012?
Offer a very short reply. -20. What is the difference between the Domestic credit (% of GDP) in Afghanistan in 2011 and the Domestic credit (% of GDP) in Mexico in 2012?
Your response must be concise. -15.31. What is the difference between the Domestic credit (% of GDP) in Afghanistan in 2011 and the Domestic credit (% of GDP) in Morocco in 2012?
Your response must be concise. -66.62. What is the difference between the Domestic credit (% of GDP) in Mexico in 2011 and the Domestic credit (% of GDP) in Morocco in 2012?
Ensure brevity in your answer.  -51.95. What is the difference between the Domestic credit (% of GDP) of Central Europe in 2011 and the Domestic credit (% of GDP) of Afghanistan in 2013?
Offer a very short reply. 47.42. What is the difference between the Domestic credit (% of GDP) in Central Europe in 2011 and the Domestic credit (% of GDP) in Mexico in 2013?
Keep it short and to the point. 29.03. What is the difference between the Domestic credit (% of GDP) of Central Europe in 2011 and the Domestic credit (% of GDP) of Morocco in 2013?
Provide a short and direct response. -16.3. What is the difference between the Domestic credit (% of GDP) of Afghanistan in 2011 and the Domestic credit (% of GDP) of Mexico in 2013?
Provide a short and direct response. -17.59. What is the difference between the Domestic credit (% of GDP) in Afghanistan in 2011 and the Domestic credit (% of GDP) in Morocco in 2013?
Provide a short and direct response. -62.92. What is the difference between the Domestic credit (% of GDP) in Mexico in 2011 and the Domestic credit (% of GDP) in Morocco in 2013?
Your response must be concise. -48.25. What is the difference between the Domestic credit (% of GDP) in Central Europe in 2012 and the Domestic credit (% of GDP) in Afghanistan in 2013?
Keep it short and to the point. 45.79. What is the difference between the Domestic credit (% of GDP) of Central Europe in 2012 and the Domestic credit (% of GDP) of Mexico in 2013?
Your answer should be compact. 27.4. What is the difference between the Domestic credit (% of GDP) in Central Europe in 2012 and the Domestic credit (% of GDP) in Morocco in 2013?
Ensure brevity in your answer.  -17.93. What is the difference between the Domestic credit (% of GDP) of Afghanistan in 2012 and the Domestic credit (% of GDP) of Mexico in 2013?
Make the answer very short. -18.46. What is the difference between the Domestic credit (% of GDP) of Afghanistan in 2012 and the Domestic credit (% of GDP) of Morocco in 2013?
Offer a terse response. -63.79. What is the difference between the Domestic credit (% of GDP) in Mexico in 2012 and the Domestic credit (% of GDP) in Morocco in 2013?
Ensure brevity in your answer.  -47.61. What is the average Domestic credit (% of GDP) in Central Europe per year?
Your response must be concise. 46.99. What is the average Domestic credit (% of GDP) of Afghanistan per year?
Ensure brevity in your answer.  7. What is the average Domestic credit (% of GDP) of Mexico per year?
Provide a succinct answer. 18.82. What is the average Domestic credit (% of GDP) of Morocco per year?
Ensure brevity in your answer.  63.03. In the year 2006, what is the difference between the Domestic credit (% of GDP) in Central Europe and Domestic credit (% of GDP) in Afghanistan?
Your answer should be very brief. 30.62. In the year 2006, what is the difference between the Domestic credit (% of GDP) of Central Europe and Domestic credit (% of GDP) of Mexico?
Keep it short and to the point. 18.86. In the year 2006, what is the difference between the Domestic credit (% of GDP) of Central Europe and Domestic credit (% of GDP) of Morocco?
Keep it short and to the point. -13.12. In the year 2006, what is the difference between the Domestic credit (% of GDP) in Afghanistan and Domestic credit (% of GDP) in Mexico?
Make the answer very short. -11.75. In the year 2006, what is the difference between the Domestic credit (% of GDP) of Afghanistan and Domestic credit (% of GDP) of Morocco?
Your response must be concise. -43.73. In the year 2006, what is the difference between the Domestic credit (% of GDP) in Mexico and Domestic credit (% of GDP) in Morocco?
Your answer should be compact. -31.98. In the year 2007, what is the difference between the Domestic credit (% of GDP) in Central Europe and Domestic credit (% of GDP) in Afghanistan?
Offer a terse response. 34.8. In the year 2007, what is the difference between the Domestic credit (% of GDP) of Central Europe and Domestic credit (% of GDP) of Mexico?
Provide a succinct answer. 23.57. In the year 2007, what is the difference between the Domestic credit (% of GDP) of Central Europe and Domestic credit (% of GDP) of Morocco?
Your response must be concise. -13.88. In the year 2007, what is the difference between the Domestic credit (% of GDP) in Afghanistan and Domestic credit (% of GDP) in Mexico?
Offer a terse response. -11.23. In the year 2007, what is the difference between the Domestic credit (% of GDP) in Afghanistan and Domestic credit (% of GDP) in Morocco?
Give a very brief answer. -48.69. In the year 2007, what is the difference between the Domestic credit (% of GDP) in Mexico and Domestic credit (% of GDP) in Morocco?
Your response must be concise. -37.46. In the year 2008, what is the difference between the Domestic credit (% of GDP) of Central Europe and Domestic credit (% of GDP) of Afghanistan?
Offer a very short reply. 39.01. In the year 2008, what is the difference between the Domestic credit (% of GDP) in Central Europe and Domestic credit (% of GDP) in Mexico?
Your answer should be compact. 31.28. In the year 2008, what is the difference between the Domestic credit (% of GDP) in Central Europe and Domestic credit (% of GDP) in Morocco?
Offer a very short reply. -12.28. In the year 2008, what is the difference between the Domestic credit (% of GDP) in Afghanistan and Domestic credit (% of GDP) in Mexico?
Provide a short and direct response. -7.73. In the year 2008, what is the difference between the Domestic credit (% of GDP) in Afghanistan and Domestic credit (% of GDP) in Morocco?
Provide a short and direct response. -51.29. In the year 2008, what is the difference between the Domestic credit (% of GDP) in Mexico and Domestic credit (% of GDP) in Morocco?
Offer a terse response. -43.56. In the year 2009, what is the difference between the Domestic credit (% of GDP) in Central Europe and Domestic credit (% of GDP) in Afghanistan?
Make the answer very short. 38.86. In the year 2009, what is the difference between the Domestic credit (% of GDP) of Central Europe and Domestic credit (% of GDP) of Mexico?
Give a very brief answer. 31.21. In the year 2009, what is the difference between the Domestic credit (% of GDP) of Central Europe and Domestic credit (% of GDP) of Morocco?
Ensure brevity in your answer.  -13.82. In the year 2009, what is the difference between the Domestic credit (% of GDP) of Afghanistan and Domestic credit (% of GDP) of Mexico?
Offer a terse response. -7.65. In the year 2009, what is the difference between the Domestic credit (% of GDP) in Afghanistan and Domestic credit (% of GDP) in Morocco?
Offer a terse response. -52.68. In the year 2009, what is the difference between the Domestic credit (% of GDP) of Mexico and Domestic credit (% of GDP) of Morocco?
Offer a very short reply. -45.03. In the year 2010, what is the difference between the Domestic credit (% of GDP) in Central Europe and Domestic credit (% of GDP) in Afghanistan?
Ensure brevity in your answer.  38.8. In the year 2010, what is the difference between the Domestic credit (% of GDP) in Central Europe and Domestic credit (% of GDP) in Mexico?
Offer a terse response. 31.85. In the year 2010, what is the difference between the Domestic credit (% of GDP) of Central Europe and Domestic credit (% of GDP) of Morocco?
Provide a short and direct response. -16.42. In the year 2010, what is the difference between the Domestic credit (% of GDP) of Afghanistan and Domestic credit (% of GDP) of Mexico?
Your response must be concise. -6.95. In the year 2010, what is the difference between the Domestic credit (% of GDP) in Afghanistan and Domestic credit (% of GDP) in Morocco?
Ensure brevity in your answer.  -55.23. In the year 2010, what is the difference between the Domestic credit (% of GDP) of Mexico and Domestic credit (% of GDP) of Morocco?
Your answer should be very brief. -48.27. In the year 2011, what is the difference between the Domestic credit (% of GDP) of Central Europe and Domestic credit (% of GDP) of Afghanistan?
Offer a terse response. 46.62. In the year 2011, what is the difference between the Domestic credit (% of GDP) of Central Europe and Domestic credit (% of GDP) of Mexico?
Provide a short and direct response. 31.96. In the year 2011, what is the difference between the Domestic credit (% of GDP) of Central Europe and Domestic credit (% of GDP) of Morocco?
Provide a short and direct response. -18.78. In the year 2011, what is the difference between the Domestic credit (% of GDP) of Afghanistan and Domestic credit (% of GDP) of Mexico?
Your response must be concise. -14.67. In the year 2011, what is the difference between the Domestic credit (% of GDP) in Afghanistan and Domestic credit (% of GDP) in Morocco?
Offer a very short reply. -65.4. In the year 2011, what is the difference between the Domestic credit (% of GDP) in Mexico and Domestic credit (% of GDP) in Morocco?
Keep it short and to the point. -50.73. In the year 2012, what is the difference between the Domestic credit (% of GDP) in Central Europe and Domestic credit (% of GDP) in Afghanistan?
Your answer should be very brief. 45.86. In the year 2012, what is the difference between the Domestic credit (% of GDP) in Central Europe and Domestic credit (% of GDP) in Mexico?
Your answer should be very brief. 29.68. In the year 2012, what is the difference between the Domestic credit (% of GDP) of Central Europe and Domestic credit (% of GDP) of Morocco?
Offer a very short reply. -21.63. In the year 2012, what is the difference between the Domestic credit (% of GDP) in Afghanistan and Domestic credit (% of GDP) in Mexico?
Provide a short and direct response. -16.18. In the year 2012, what is the difference between the Domestic credit (% of GDP) of Afghanistan and Domestic credit (% of GDP) of Morocco?
Offer a very short reply. -67.49. In the year 2012, what is the difference between the Domestic credit (% of GDP) in Mexico and Domestic credit (% of GDP) in Morocco?
Offer a very short reply. -51.31. In the year 2013, what is the difference between the Domestic credit (% of GDP) of Central Europe and Domestic credit (% of GDP) of Afghanistan?
Keep it short and to the point. 45.32. In the year 2013, what is the difference between the Domestic credit (% of GDP) in Central Europe and Domestic credit (% of GDP) in Mexico?
Offer a terse response. 26.94. In the year 2013, what is the difference between the Domestic credit (% of GDP) in Central Europe and Domestic credit (% of GDP) in Morocco?
Provide a succinct answer. -18.39. In the year 2013, what is the difference between the Domestic credit (% of GDP) of Afghanistan and Domestic credit (% of GDP) of Mexico?
Ensure brevity in your answer.  -18.38. In the year 2013, what is the difference between the Domestic credit (% of GDP) of Afghanistan and Domestic credit (% of GDP) of Morocco?
Offer a very short reply. -63.72. In the year 2013, what is the difference between the Domestic credit (% of GDP) of Mexico and Domestic credit (% of GDP) of Morocco?
Keep it short and to the point. -45.33. What is the ratio of the Domestic credit (% of GDP) in Central Europe in 2006 to that in 2007?
Offer a terse response. 0.85. What is the ratio of the Domestic credit (% of GDP) of Afghanistan in 2006 to that in 2007?
Ensure brevity in your answer.  0.71. What is the ratio of the Domestic credit (% of GDP) of Mexico in 2006 to that in 2007?
Offer a very short reply. 0.92. What is the ratio of the Domestic credit (% of GDP) in Morocco in 2006 to that in 2007?
Your answer should be compact. 0.87. What is the ratio of the Domestic credit (% of GDP) in Central Europe in 2006 to that in 2008?
Offer a very short reply. 0.73. What is the ratio of the Domestic credit (% of GDP) of Afghanistan in 2006 to that in 2008?
Make the answer very short. 0.51. What is the ratio of the Domestic credit (% of GDP) of Mexico in 2006 to that in 2008?
Offer a very short reply. 0.97. What is the ratio of the Domestic credit (% of GDP) in Morocco in 2006 to that in 2008?
Your answer should be very brief. 0.8. What is the ratio of the Domestic credit (% of GDP) of Central Europe in 2006 to that in 2009?
Offer a terse response. 0.72. What is the ratio of the Domestic credit (% of GDP) of Afghanistan in 2006 to that in 2009?
Provide a short and direct response. 0.45. What is the ratio of the Domestic credit (% of GDP) in Mexico in 2006 to that in 2009?
Ensure brevity in your answer.  0.91. What is the ratio of the Domestic credit (% of GDP) in Morocco in 2006 to that in 2009?
Your answer should be very brief. 0.77. What is the ratio of the Domestic credit (% of GDP) of Central Europe in 2006 to that in 2010?
Provide a succinct answer. 0.7. What is the ratio of the Domestic credit (% of GDP) of Afghanistan in 2006 to that in 2010?
Ensure brevity in your answer.  0.42. What is the ratio of the Domestic credit (% of GDP) in Mexico in 2006 to that in 2010?
Your answer should be compact. 0.9. What is the ratio of the Domestic credit (% of GDP) of Morocco in 2006 to that in 2010?
Provide a succinct answer. 0.73. What is the ratio of the Domestic credit (% of GDP) of Central Europe in 2006 to that in 2011?
Make the answer very short. 0.69. What is the ratio of the Domestic credit (% of GDP) of Afghanistan in 2006 to that in 2011?
Offer a terse response. 0.97. What is the ratio of the Domestic credit (% of GDP) of Mexico in 2006 to that in 2011?
Your response must be concise. 0.84. What is the ratio of the Domestic credit (% of GDP) in Morocco in 2006 to that in 2011?
Offer a terse response. 0.69. What is the ratio of the Domestic credit (% of GDP) in Central Europe in 2006 to that in 2012?
Your answer should be compact. 0.71. What is the ratio of the Domestic credit (% of GDP) in Afghanistan in 2006 to that in 2012?
Ensure brevity in your answer.  1.18. What is the ratio of the Domestic credit (% of GDP) of Mexico in 2006 to that in 2012?
Provide a succinct answer. 0.82. What is the ratio of the Domestic credit (% of GDP) of Morocco in 2006 to that in 2012?
Your answer should be very brief. 0.68. What is the ratio of the Domestic credit (% of GDP) of Central Europe in 2006 to that in 2013?
Provide a short and direct response. 0.72. What is the ratio of the Domestic credit (% of GDP) in Afghanistan in 2006 to that in 2013?
Keep it short and to the point. 1.16. What is the ratio of the Domestic credit (% of GDP) in Mexico in 2006 to that in 2013?
Offer a terse response. 0.73. What is the ratio of the Domestic credit (% of GDP) in Morocco in 2006 to that in 2013?
Provide a short and direct response. 0.72. What is the ratio of the Domestic credit (% of GDP) of Central Europe in 2007 to that in 2008?
Make the answer very short. 0.86. What is the ratio of the Domestic credit (% of GDP) of Afghanistan in 2007 to that in 2008?
Keep it short and to the point. 0.73. What is the ratio of the Domestic credit (% of GDP) in Mexico in 2007 to that in 2008?
Offer a very short reply. 1.06. What is the ratio of the Domestic credit (% of GDP) of Morocco in 2007 to that in 2008?
Offer a terse response. 0.92. What is the ratio of the Domestic credit (% of GDP) of Central Europe in 2007 to that in 2009?
Make the answer very short. 0.84. What is the ratio of the Domestic credit (% of GDP) in Afghanistan in 2007 to that in 2009?
Your answer should be compact. 0.64. What is the ratio of the Domestic credit (% of GDP) of Mexico in 2007 to that in 2009?
Offer a terse response. 0.99. What is the ratio of the Domestic credit (% of GDP) in Morocco in 2007 to that in 2009?
Offer a very short reply. 0.88. What is the ratio of the Domestic credit (% of GDP) of Central Europe in 2007 to that in 2010?
Your response must be concise. 0.83. What is the ratio of the Domestic credit (% of GDP) of Afghanistan in 2007 to that in 2010?
Provide a short and direct response. 0.59. What is the ratio of the Domestic credit (% of GDP) of Mexico in 2007 to that in 2010?
Ensure brevity in your answer.  0.97. What is the ratio of the Domestic credit (% of GDP) in Morocco in 2007 to that in 2010?
Provide a succinct answer. 0.83. What is the ratio of the Domestic credit (% of GDP) of Central Europe in 2007 to that in 2011?
Your answer should be very brief. 0.81. What is the ratio of the Domestic credit (% of GDP) of Afghanistan in 2007 to that in 2011?
Keep it short and to the point. 1.37. What is the ratio of the Domestic credit (% of GDP) of Mexico in 2007 to that in 2011?
Your response must be concise. 0.92. What is the ratio of the Domestic credit (% of GDP) of Morocco in 2007 to that in 2011?
Ensure brevity in your answer.  0.79. What is the ratio of the Domestic credit (% of GDP) of Central Europe in 2007 to that in 2012?
Offer a terse response. 0.83. What is the ratio of the Domestic credit (% of GDP) of Afghanistan in 2007 to that in 2012?
Your response must be concise. 1.67. What is the ratio of the Domestic credit (% of GDP) in Mexico in 2007 to that in 2012?
Offer a terse response. 0.89. What is the ratio of the Domestic credit (% of GDP) of Morocco in 2007 to that in 2012?
Offer a terse response. 0.78. What is the ratio of the Domestic credit (% of GDP) in Central Europe in 2007 to that in 2013?
Give a very brief answer. 0.84. What is the ratio of the Domestic credit (% of GDP) in Afghanistan in 2007 to that in 2013?
Your answer should be very brief. 1.64. What is the ratio of the Domestic credit (% of GDP) of Mexico in 2007 to that in 2013?
Offer a very short reply. 0.8. What is the ratio of the Domestic credit (% of GDP) in Morocco in 2007 to that in 2013?
Your response must be concise. 0.82. What is the ratio of the Domestic credit (% of GDP) of Central Europe in 2008 to that in 2009?
Ensure brevity in your answer.  0.98. What is the ratio of the Domestic credit (% of GDP) of Afghanistan in 2008 to that in 2009?
Your response must be concise. 0.88. What is the ratio of the Domestic credit (% of GDP) in Mexico in 2008 to that in 2009?
Make the answer very short. 0.94. What is the ratio of the Domestic credit (% of GDP) of Morocco in 2008 to that in 2009?
Provide a short and direct response. 0.96. What is the ratio of the Domestic credit (% of GDP) of Central Europe in 2008 to that in 2010?
Make the answer very short. 0.96. What is the ratio of the Domestic credit (% of GDP) in Afghanistan in 2008 to that in 2010?
Your response must be concise. 0.81. What is the ratio of the Domestic credit (% of GDP) in Mexico in 2008 to that in 2010?
Your answer should be very brief. 0.92. What is the ratio of the Domestic credit (% of GDP) in Morocco in 2008 to that in 2010?
Offer a very short reply. 0.91. What is the ratio of the Domestic credit (% of GDP) in Central Europe in 2008 to that in 2011?
Your answer should be very brief. 0.94. What is the ratio of the Domestic credit (% of GDP) of Afghanistan in 2008 to that in 2011?
Your response must be concise. 1.89. What is the ratio of the Domestic credit (% of GDP) in Mexico in 2008 to that in 2011?
Ensure brevity in your answer.  0.87. What is the ratio of the Domestic credit (% of GDP) in Morocco in 2008 to that in 2011?
Keep it short and to the point. 0.86. What is the ratio of the Domestic credit (% of GDP) of Central Europe in 2008 to that in 2012?
Give a very brief answer. 0.97. What is the ratio of the Domestic credit (% of GDP) of Afghanistan in 2008 to that in 2012?
Make the answer very short. 2.3. What is the ratio of the Domestic credit (% of GDP) of Mexico in 2008 to that in 2012?
Provide a short and direct response. 0.84. What is the ratio of the Domestic credit (% of GDP) of Morocco in 2008 to that in 2012?
Your answer should be very brief. 0.85. What is the ratio of the Domestic credit (% of GDP) in Central Europe in 2008 to that in 2013?
Ensure brevity in your answer.  0.98. What is the ratio of the Domestic credit (% of GDP) of Afghanistan in 2008 to that in 2013?
Offer a terse response. 2.25. What is the ratio of the Domestic credit (% of GDP) in Mexico in 2008 to that in 2013?
Provide a short and direct response. 0.76. What is the ratio of the Domestic credit (% of GDP) of Morocco in 2008 to that in 2013?
Your response must be concise. 0.89. What is the ratio of the Domestic credit (% of GDP) in Central Europe in 2009 to that in 2010?
Ensure brevity in your answer.  0.98. What is the ratio of the Domestic credit (% of GDP) in Afghanistan in 2009 to that in 2010?
Ensure brevity in your answer.  0.91. What is the ratio of the Domestic credit (% of GDP) in Mexico in 2009 to that in 2010?
Your response must be concise. 0.98. What is the ratio of the Domestic credit (% of GDP) of Morocco in 2009 to that in 2010?
Your response must be concise. 0.95. What is the ratio of the Domestic credit (% of GDP) in Central Europe in 2009 to that in 2011?
Provide a short and direct response. 0.96. What is the ratio of the Domestic credit (% of GDP) in Afghanistan in 2009 to that in 2011?
Keep it short and to the point. 2.14. What is the ratio of the Domestic credit (% of GDP) in Mexico in 2009 to that in 2011?
Provide a succinct answer. 0.93. What is the ratio of the Domestic credit (% of GDP) in Morocco in 2009 to that in 2011?
Your answer should be compact. 0.9. What is the ratio of the Domestic credit (% of GDP) in Afghanistan in 2009 to that in 2012?
Make the answer very short. 2.6. What is the ratio of the Domestic credit (% of GDP) of Mexico in 2009 to that in 2012?
Your response must be concise. 0.9. What is the ratio of the Domestic credit (% of GDP) in Morocco in 2009 to that in 2012?
Your answer should be very brief. 0.88. What is the ratio of the Domestic credit (% of GDP) of Central Europe in 2009 to that in 2013?
Offer a very short reply. 1. What is the ratio of the Domestic credit (% of GDP) in Afghanistan in 2009 to that in 2013?
Offer a terse response. 2.55. What is the ratio of the Domestic credit (% of GDP) in Mexico in 2009 to that in 2013?
Your response must be concise. 0.81. What is the ratio of the Domestic credit (% of GDP) of Morocco in 2009 to that in 2013?
Make the answer very short. 0.93. What is the ratio of the Domestic credit (% of GDP) in Central Europe in 2010 to that in 2011?
Keep it short and to the point. 0.98. What is the ratio of the Domestic credit (% of GDP) in Afghanistan in 2010 to that in 2011?
Your answer should be compact. 2.34. What is the ratio of the Domestic credit (% of GDP) in Mexico in 2010 to that in 2011?
Keep it short and to the point. 0.94. What is the ratio of the Domestic credit (% of GDP) of Morocco in 2010 to that in 2011?
Your response must be concise. 0.95. What is the ratio of the Domestic credit (% of GDP) in Afghanistan in 2010 to that in 2012?
Give a very brief answer. 2.84. What is the ratio of the Domestic credit (% of GDP) in Mexico in 2010 to that in 2012?
Provide a short and direct response. 0.91. What is the ratio of the Domestic credit (% of GDP) in Morocco in 2010 to that in 2012?
Ensure brevity in your answer.  0.93. What is the ratio of the Domestic credit (% of GDP) in Central Europe in 2010 to that in 2013?
Offer a terse response. 1.02. What is the ratio of the Domestic credit (% of GDP) in Afghanistan in 2010 to that in 2013?
Offer a very short reply. 2.79. What is the ratio of the Domestic credit (% of GDP) of Mexico in 2010 to that in 2013?
Ensure brevity in your answer.  0.82. What is the ratio of the Domestic credit (% of GDP) of Morocco in 2010 to that in 2013?
Your answer should be compact. 0.98. What is the ratio of the Domestic credit (% of GDP) of Central Europe in 2011 to that in 2012?
Your response must be concise. 1.03. What is the ratio of the Domestic credit (% of GDP) in Afghanistan in 2011 to that in 2012?
Provide a short and direct response. 1.22. What is the ratio of the Domestic credit (% of GDP) of Mexico in 2011 to that in 2012?
Keep it short and to the point. 0.97. What is the ratio of the Domestic credit (% of GDP) of Central Europe in 2011 to that in 2013?
Provide a short and direct response. 1.04. What is the ratio of the Domestic credit (% of GDP) of Afghanistan in 2011 to that in 2013?
Keep it short and to the point. 1.19. What is the ratio of the Domestic credit (% of GDP) of Mexico in 2011 to that in 2013?
Make the answer very short. 0.87. What is the ratio of the Domestic credit (% of GDP) in Morocco in 2011 to that in 2013?
Give a very brief answer. 1.04. What is the ratio of the Domestic credit (% of GDP) in Central Europe in 2012 to that in 2013?
Keep it short and to the point. 1.01. What is the ratio of the Domestic credit (% of GDP) in Afghanistan in 2012 to that in 2013?
Your answer should be very brief. 0.98. What is the ratio of the Domestic credit (% of GDP) of Mexico in 2012 to that in 2013?
Keep it short and to the point. 0.9. What is the ratio of the Domestic credit (% of GDP) of Morocco in 2012 to that in 2013?
Provide a short and direct response. 1.05. What is the difference between the highest and the second highest Domestic credit (% of GDP) of Central Europe?
Give a very brief answer. 1.23. What is the difference between the highest and the second highest Domestic credit (% of GDP) of Mexico?
Provide a short and direct response. 2.28. What is the difference between the highest and the second highest Domestic credit (% of GDP) in Morocco?
Keep it short and to the point. 1.22. What is the difference between the highest and the lowest Domestic credit (% of GDP) in Central Europe?
Provide a short and direct response. 16.15. What is the difference between the highest and the lowest Domestic credit (% of GDP) of Afghanistan?
Offer a terse response. 7.46. What is the difference between the highest and the lowest Domestic credit (% of GDP) in Mexico?
Offer a terse response. 5.98. What is the difference between the highest and the lowest Domestic credit (% of GDP) of Morocco?
Provide a succinct answer. 23.03. 